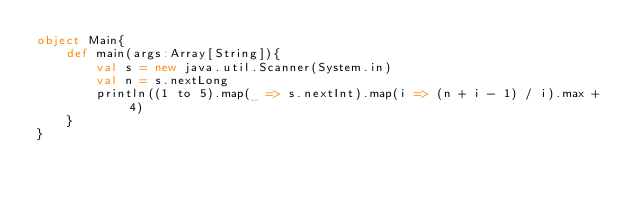Convert code to text. <code><loc_0><loc_0><loc_500><loc_500><_Scala_>object Main{
	def main(args:Array[String]){
		val s = new java.util.Scanner(System.in)
		val n = s.nextLong
		println((1 to 5).map(_ => s.nextInt).map(i => (n + i - 1) / i).max + 4)
	}
}</code> 